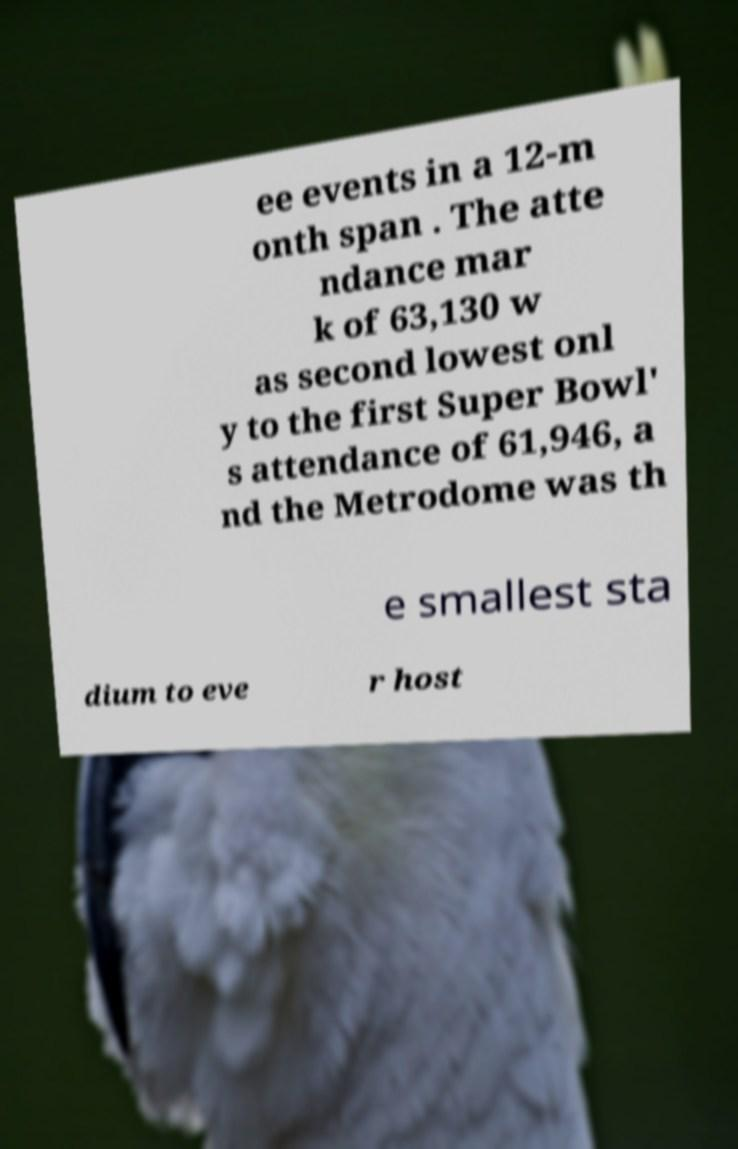I need the written content from this picture converted into text. Can you do that? ee events in a 12-m onth span . The atte ndance mar k of 63,130 w as second lowest onl y to the first Super Bowl' s attendance of 61,946, a nd the Metrodome was th e smallest sta dium to eve r host 